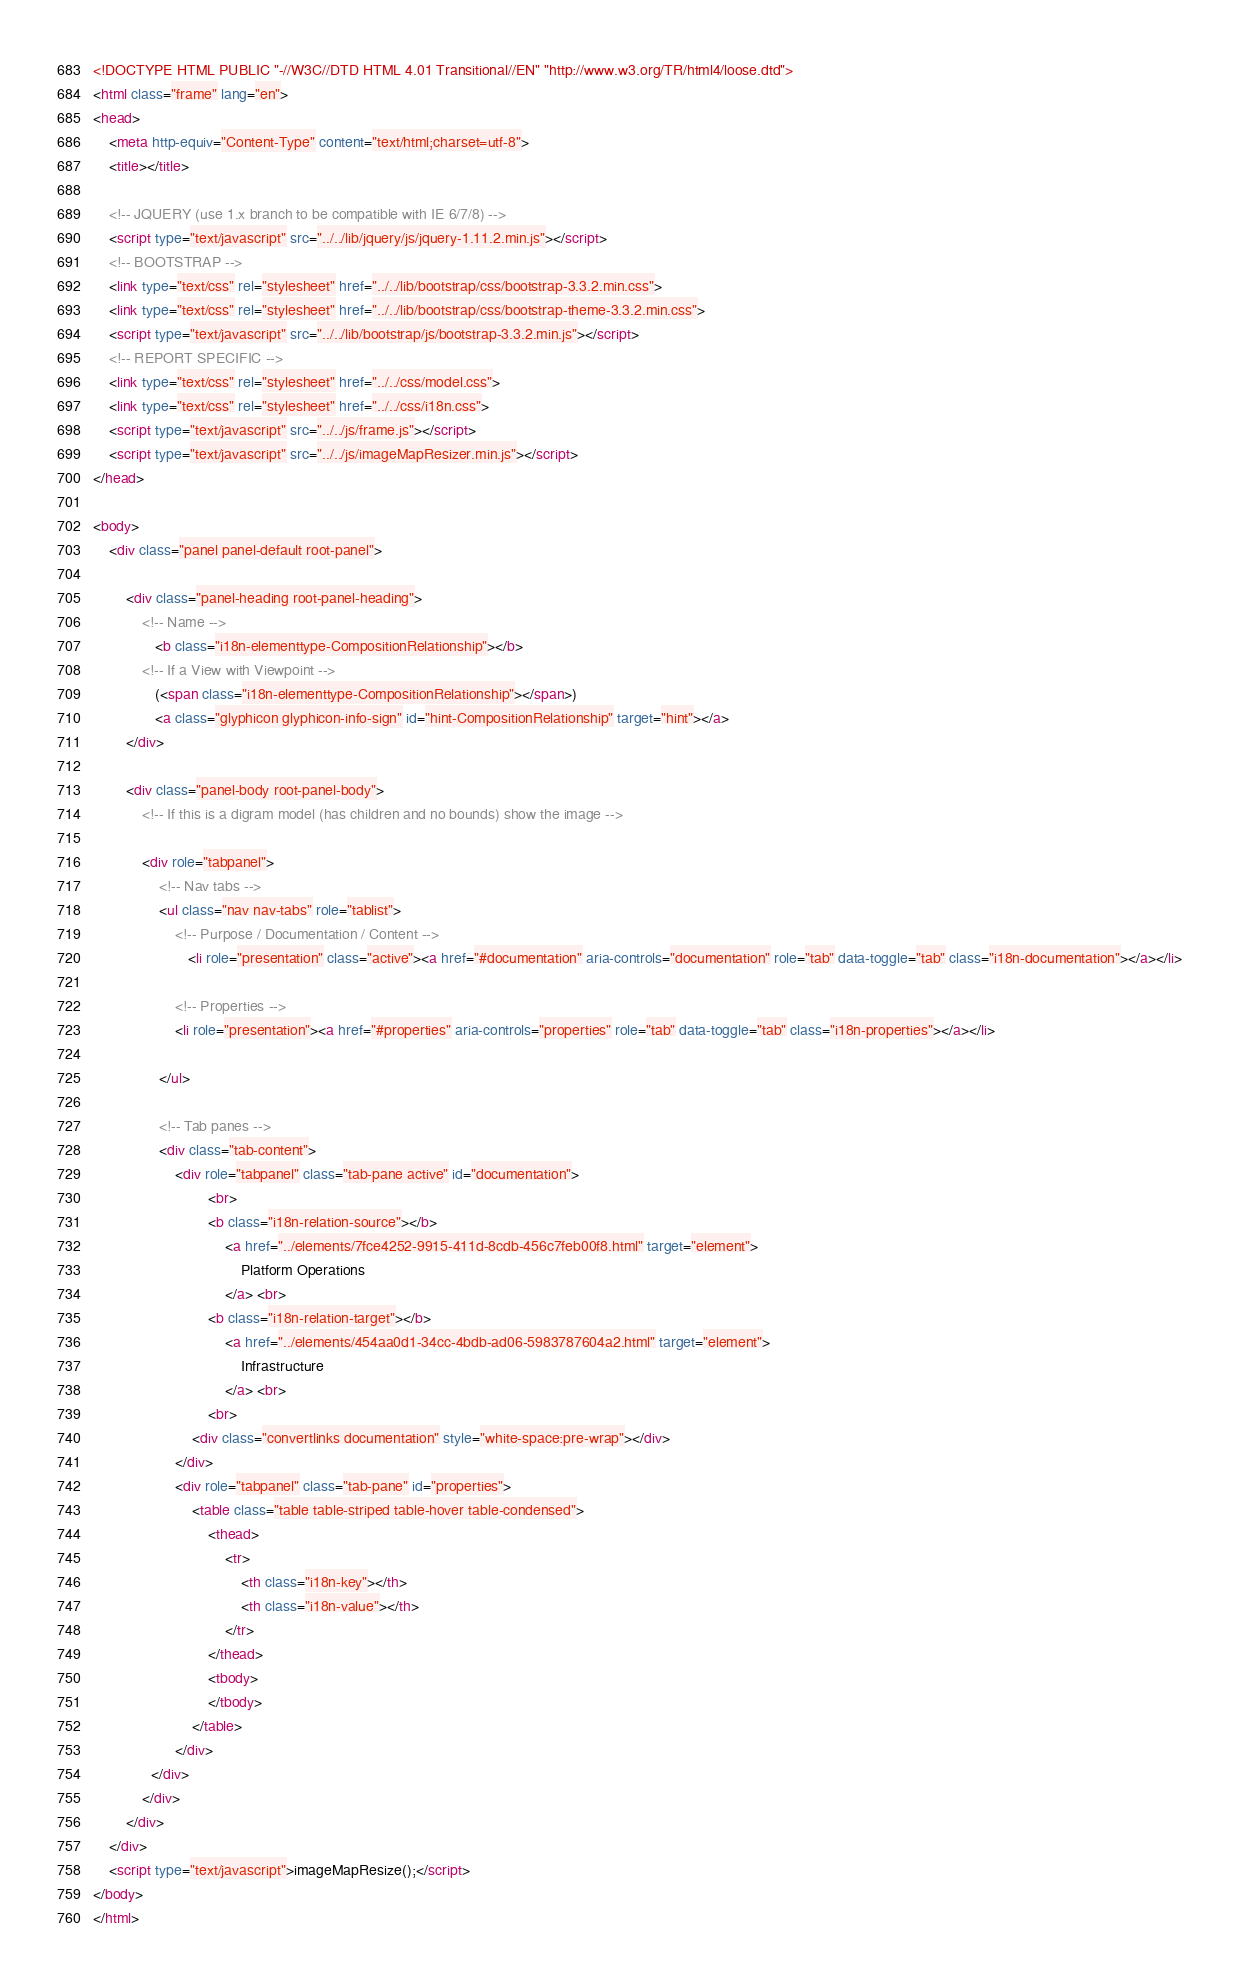<code> <loc_0><loc_0><loc_500><loc_500><_HTML_><!DOCTYPE HTML PUBLIC "-//W3C//DTD HTML 4.01 Transitional//EN" "http://www.w3.org/TR/html4/loose.dtd">
<html class="frame" lang="en">
<head>
	<meta http-equiv="Content-Type" content="text/html;charset=utf-8">
	<title></title>

	<!-- JQUERY (use 1.x branch to be compatible with IE 6/7/8) -->
	<script type="text/javascript" src="../../lib/jquery/js/jquery-1.11.2.min.js"></script>
	<!-- BOOTSTRAP -->
	<link type="text/css" rel="stylesheet" href="../../lib/bootstrap/css/bootstrap-3.3.2.min.css">
	<link type="text/css" rel="stylesheet" href="../../lib/bootstrap/css/bootstrap-theme-3.3.2.min.css">
	<script type="text/javascript" src="../../lib/bootstrap/js/bootstrap-3.3.2.min.js"></script>
	<!-- REPORT SPECIFIC -->
	<link type="text/css" rel="stylesheet" href="../../css/model.css">
	<link type="text/css" rel="stylesheet" href="../../css/i18n.css">
	<script type="text/javascript" src="../../js/frame.js"></script>
	<script type="text/javascript" src="../../js/imageMapResizer.min.js"></script>
</head>

<body>
	<div class="panel panel-default root-panel">

		<div class="panel-heading root-panel-heading">
            <!-- Name -->
               <b class="i18n-elementtype-CompositionRelationship"></b>
            <!-- If a View with Viewpoint -->
			   (<span class="i18n-elementtype-CompositionRelationship"></span>)
			   <a class="glyphicon glyphicon-info-sign" id="hint-CompositionRelationship" target="hint"></a>
		</div>

		<div class="panel-body root-panel-body">
		    <!-- If this is a digram model (has children and no bounds) show the image -->

			<div role="tabpanel">
				<!-- Nav tabs -->
				<ul class="nav nav-tabs" role="tablist">
                    <!-- Purpose / Documentation / Content -->
					   <li role="presentation" class="active"><a href="#documentation" aria-controls="documentation" role="tab" data-toggle="tab" class="i18n-documentation"></a></li>

                    <!-- Properties -->
                    <li role="presentation"><a href="#properties" aria-controls="properties" role="tab" data-toggle="tab" class="i18n-properties"></a></li>

				</ul>

				<!-- Tab panes -->
				<div class="tab-content">
					<div role="tabpanel" class="tab-pane active" id="documentation">
							<br>
							<b class="i18n-relation-source"></b>
								<a href="../elements/7fce4252-9915-411d-8cdb-456c7feb00f8.html" target="element">
									Platform Operations
								</a> <br>
							<b class="i18n-relation-target"></b>
								<a href="../elements/454aa0d1-34cc-4bdb-ad06-5983787604a2.html" target="element">
									Infrastructure
								</a> <br>
							<br>
						<div class="convertlinks documentation" style="white-space:pre-wrap"></div>
					</div>
					<div role="tabpanel" class="tab-pane" id="properties">
						<table class="table table-striped table-hover table-condensed">
							<thead>
								<tr>
									<th class="i18n-key"></th>
									<th class="i18n-value"></th>
								</tr>
							</thead>
							<tbody>
							</tbody>
						</table>
					</div>
			  </div>
			</div>
		</div>
	</div>
	<script type="text/javascript">imageMapResize();</script>
</body>
</html></code> 